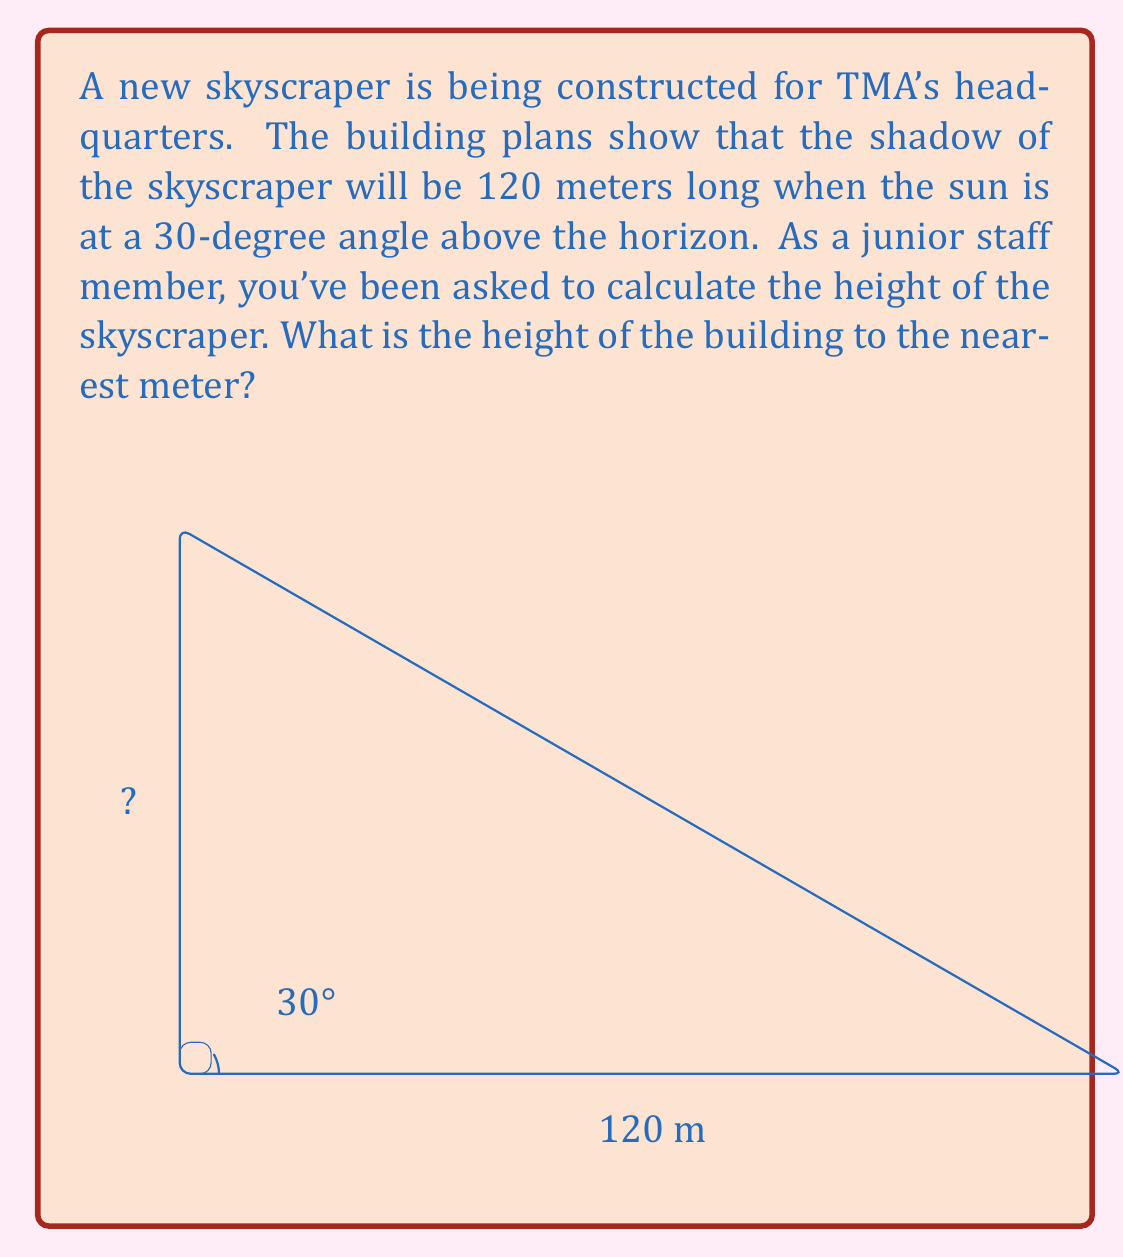Help me with this question. Let's approach this problem step-by-step using the Pythagorean theorem and similar triangles:

1) First, we need to recognize that the skyscraper, its shadow, and the sun's rays form a right triangle. The angle between the ground and the sun's rays is 30°.

2) In a 30-60-90 triangle, the ratio of sides is 1 : $\sqrt{3}$ : 2. We can use this to set up a similar triangle to our problem.

3) Let's call the height of the skyscraper $h$ and the length of the shadow $s$. We know $s = 120$ m.

4) The ratio of the height to the shadow length should be the same as $\sqrt{3}$ : 2 in a 30-60-90 triangle.

   $$\frac{h}{s} = \frac{\sqrt{3}}{2}$$

5) Substituting the known value of $s$:

   $$\frac{h}{120} = \frac{\sqrt{3}}{2}$$

6) Solve for $h$:

   $$h = 120 \cdot \frac{\sqrt{3}}{2} = 60\sqrt{3}$$

7) Calculate the value:

   $$60\sqrt{3} \approx 103.92$$

8) Rounding to the nearest meter:

   $h \approx 104$ meters

Therefore, the height of the skyscraper is approximately 104 meters.
Answer: 104 meters 